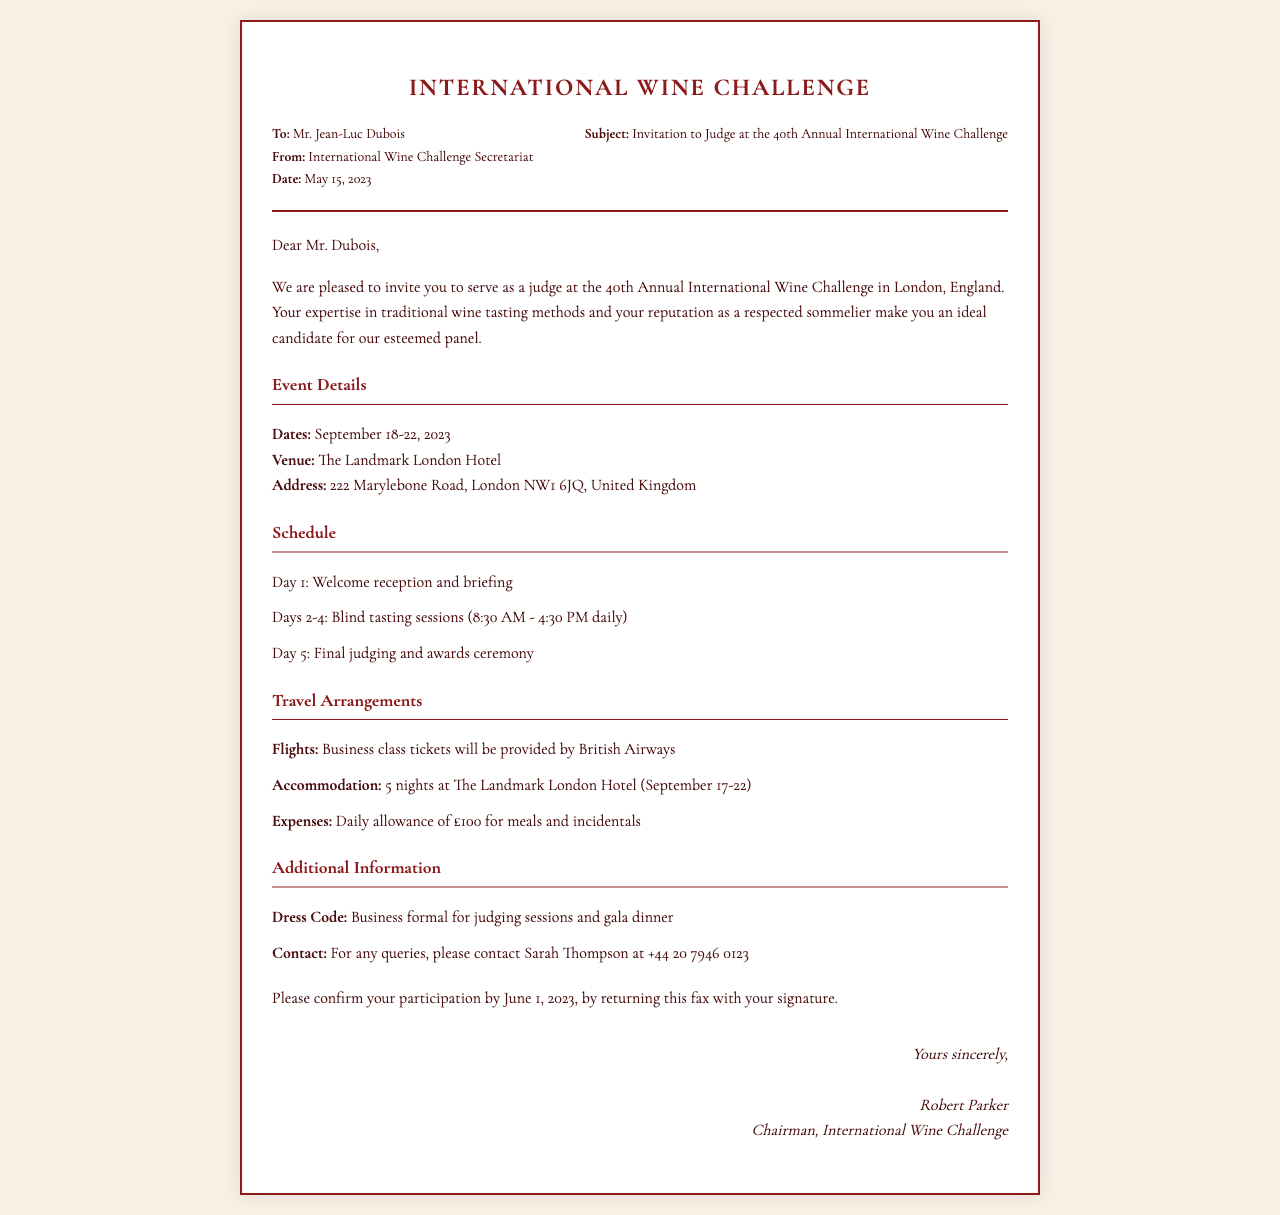What are the event dates? The event dates are mentioned in the event details section of the document.
Answer: September 18-22, 2023 What is the venue of the competition? The venue is specified in the event details section.
Answer: The Landmark London Hotel Who should be contacted for queries? The contact person's name and details are provided in the additional information section.
Answer: Sarah Thompson What dress code is required for the judging sessions? The dress code is highlighted in the additional information section.
Answer: Business formal What is the daily allowance for expenses? The daily allowance is clearly stated in the travel arrangements section.
Answer: £100 When is the confirmation deadline? The confirmation deadline is mentioned in the closing section of the document.
Answer: June 1, 2023 How many nights will accommodation be provided? The number of nights can be found in the travel arrangements section.
Answer: 5 nights What is the subject of the fax? The subject line is provided in the header details section of the document.
Answer: Invitation to Judge at the 40th Annual International Wine Challenge What is the role of Mr. Jean-Luc Dubois in the event? Mr. Dubois' role is indicated in the invitation section of the document.
Answer: Judge 